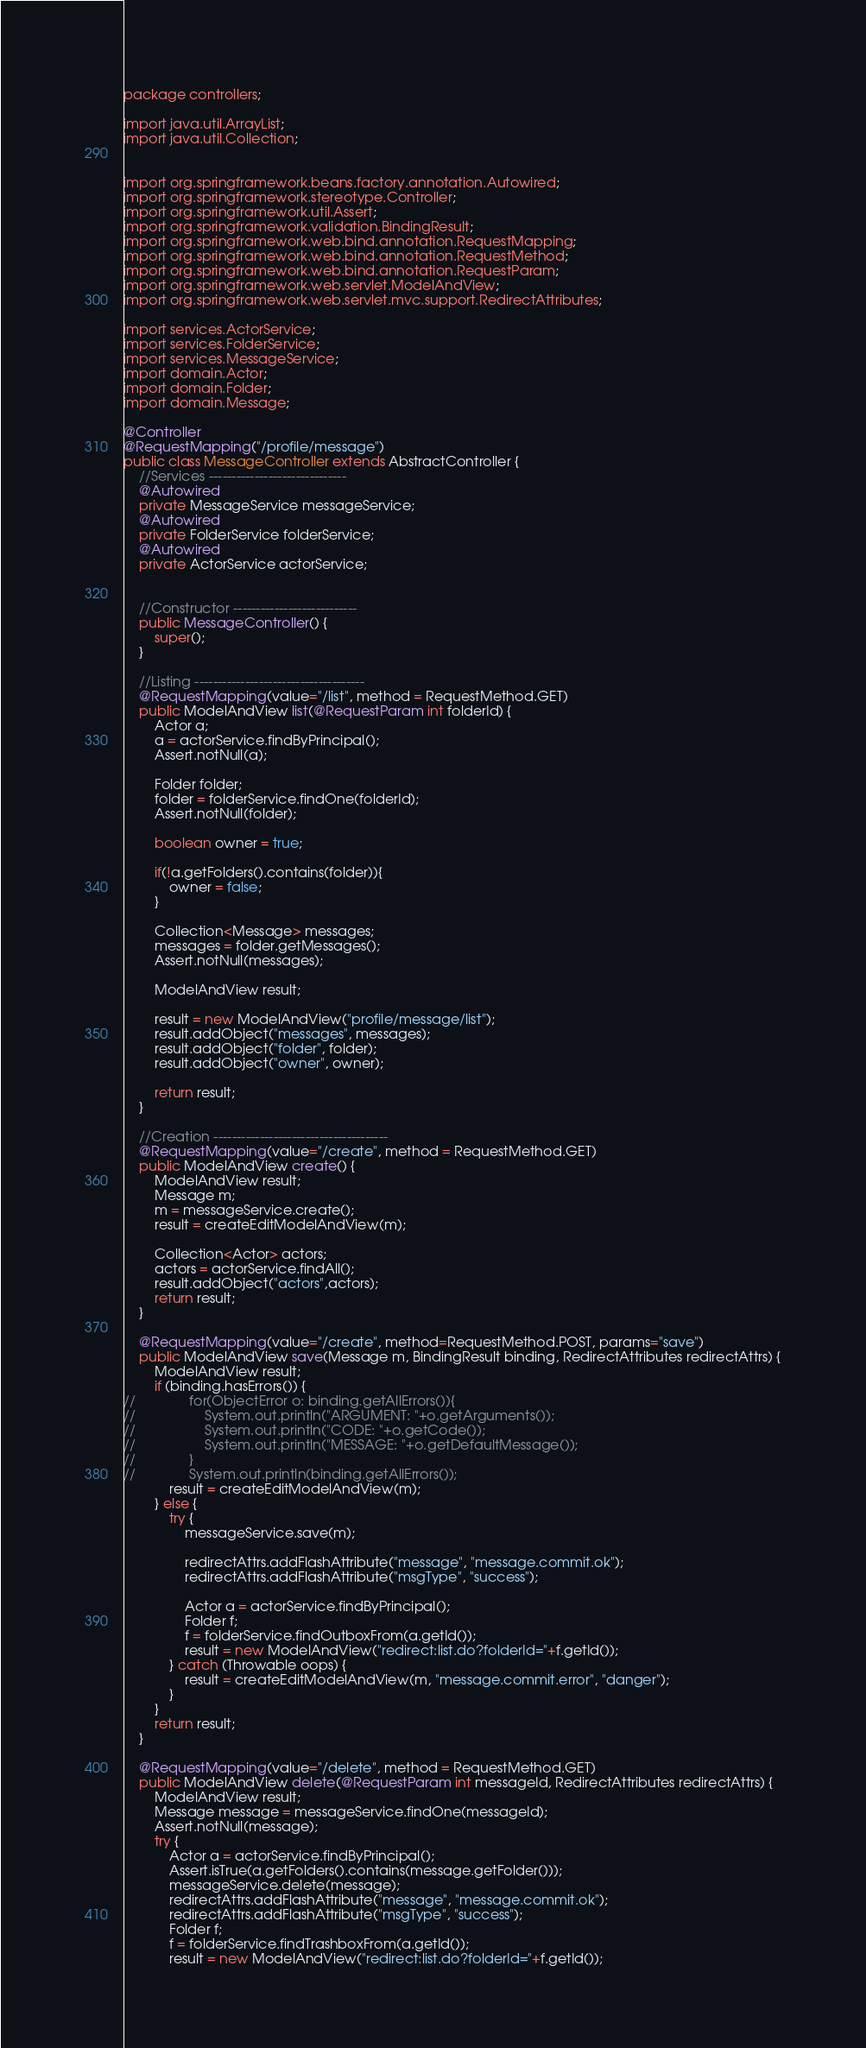Convert code to text. <code><loc_0><loc_0><loc_500><loc_500><_Java_>package controllers;

import java.util.ArrayList;
import java.util.Collection;


import org.springframework.beans.factory.annotation.Autowired;
import org.springframework.stereotype.Controller;
import org.springframework.util.Assert;
import org.springframework.validation.BindingResult;
import org.springframework.web.bind.annotation.RequestMapping;
import org.springframework.web.bind.annotation.RequestMethod;
import org.springframework.web.bind.annotation.RequestParam;
import org.springframework.web.servlet.ModelAndView;
import org.springframework.web.servlet.mvc.support.RedirectAttributes;

import services.ActorService;
import services.FolderService;
import services.MessageService;
import domain.Actor;
import domain.Folder;
import domain.Message;

@Controller
@RequestMapping("/profile/message")
public class MessageController extends AbstractController {
	//Services ------------------------------
	@Autowired
	private MessageService messageService;
	@Autowired
	private FolderService folderService;
	@Autowired
	private ActorService actorService;

	
	//Constructor ---------------------------
	public MessageController() {
		super();
	}
	
	//Listing -------------------------------------
	@RequestMapping(value="/list", method = RequestMethod.GET)
	public ModelAndView list(@RequestParam int folderId) {
		Actor a;
		a = actorService.findByPrincipal();
		Assert.notNull(a);
		
		Folder folder;
		folder = folderService.findOne(folderId);
		Assert.notNull(folder);
		
		boolean owner = true;
		
		if(!a.getFolders().contains(folder)){
			owner = false;
		}
		
		Collection<Message> messages;
		messages = folder.getMessages();
		Assert.notNull(messages);
		
		ModelAndView result;
			
		result = new ModelAndView("profile/message/list");
		result.addObject("messages", messages);
		result.addObject("folder", folder);
		result.addObject("owner", owner);

		return result;	
	}
	
	//Creation --------------------------------------
	@RequestMapping(value="/create", method = RequestMethod.GET)
	public ModelAndView create() {
		ModelAndView result;
		Message m;
		m = messageService.create();
		result = createEditModelAndView(m);
		
		Collection<Actor> actors;
		actors = actorService.findAll();
		result.addObject("actors",actors);
		return result;
	}
	
	@RequestMapping(value="/create", method=RequestMethod.POST, params="save")
	public ModelAndView save(Message m, BindingResult binding, RedirectAttributes redirectAttrs) {
		ModelAndView result;
		if (binding.hasErrors()) {
//				for(ObjectError o: binding.getAllErrors()){
//					System.out.println("ARGUMENT: "+o.getArguments());
//					System.out.println("CODE: "+o.getCode());
//					System.out.println("MESSAGE: "+o.getDefaultMessage());
//				}
//				System.out.println(binding.getAllErrors());
			result = createEditModelAndView(m);
		} else {
			try {
				messageService.save(m);

				redirectAttrs.addFlashAttribute("message", "message.commit.ok");
				redirectAttrs.addFlashAttribute("msgType", "success");
				
				Actor a = actorService.findByPrincipal();
				Folder f;
				f = folderService.findOutboxFrom(a.getId());
				result = new ModelAndView("redirect:list.do?folderId="+f.getId());
			} catch (Throwable oops) {
				result = createEditModelAndView(m, "message.commit.error", "danger");
			}
		}
		return result;
	}
	
	@RequestMapping(value="/delete", method = RequestMethod.GET)
	public ModelAndView delete(@RequestParam int messageId, RedirectAttributes redirectAttrs) {
		ModelAndView result;
		Message message = messageService.findOne(messageId);
		Assert.notNull(message);
		try {
			Actor a = actorService.findByPrincipal();
			Assert.isTrue(a.getFolders().contains(message.getFolder()));
			messageService.delete(message);
			redirectAttrs.addFlashAttribute("message", "message.commit.ok");
			redirectAttrs.addFlashAttribute("msgType", "success");
			Folder f;
			f = folderService.findTrashboxFrom(a.getId());
			result = new ModelAndView("redirect:list.do?folderId="+f.getId());</code> 